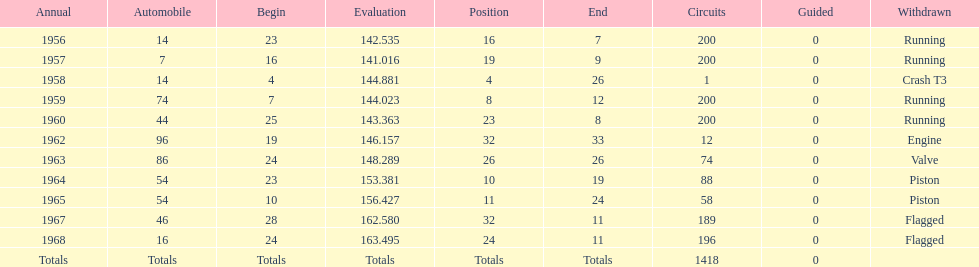What was the last year that it finished the race? 1968. 